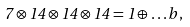<formula> <loc_0><loc_0><loc_500><loc_500>7 \otimes 1 4 \otimes 1 4 \otimes 1 4 = 1 \oplus \dots b \, ,</formula> 